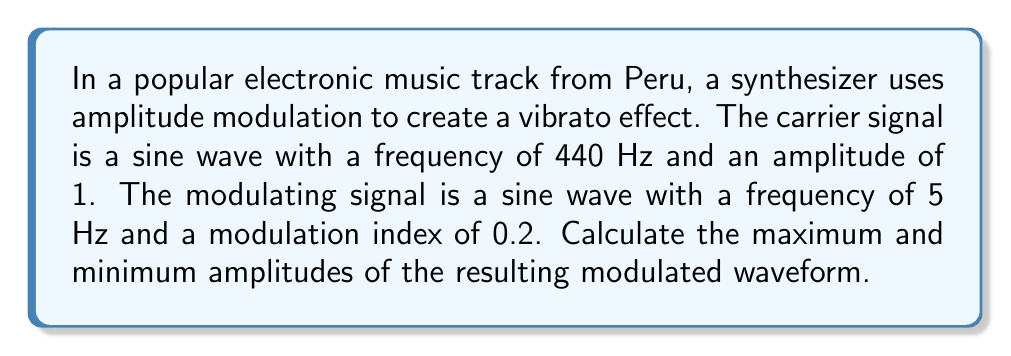Could you help me with this problem? To solve this problem, we'll follow these steps:

1) The general equation for amplitude modulation is:

   $$y(t) = A_c[1 + m \sin(2\pi f_m t)] \sin(2\pi f_c t)$$

   Where:
   $A_c$ is the amplitude of the carrier signal
   $m$ is the modulation index
   $f_m$ is the frequency of the modulating signal
   $f_c$ is the frequency of the carrier signal

2) In this case:
   $A_c = 1$
   $m = 0.2$
   $f_m = 5$ Hz
   $f_c = 440$ Hz

3) The maximum amplitude occurs when the modulating signal reaches its peak:

   $$A_{max} = A_c(1 + m) = 1(1 + 0.2) = 1.2$$

4) The minimum amplitude occurs when the modulating signal reaches its trough:

   $$A_{min} = A_c(1 - m) = 1(1 - 0.2) = 0.8$$

5) Therefore, the amplitude of the modulated signal varies between 0.8 and 1.2.
Answer: $A_{max} = 1.2$, $A_{min} = 0.8$ 